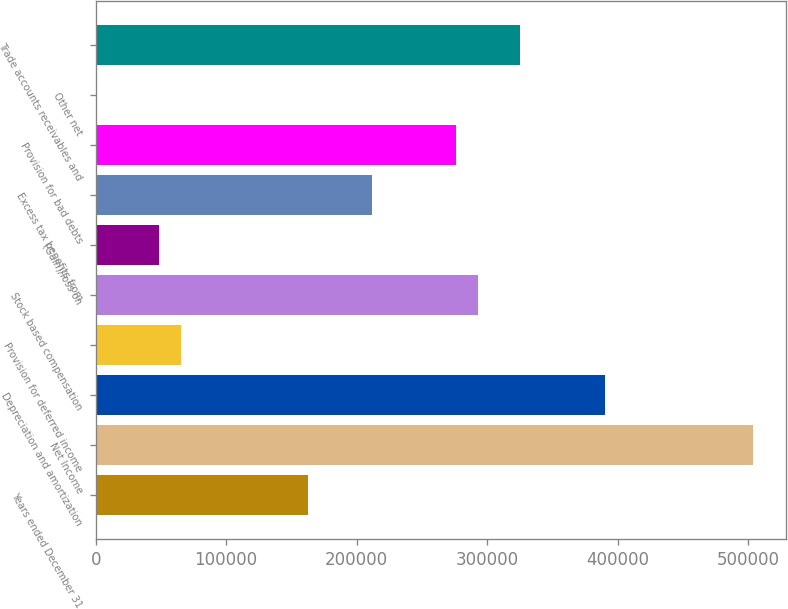<chart> <loc_0><loc_0><loc_500><loc_500><bar_chart><fcel>Years ended December 31<fcel>Net Income<fcel>Depreciation and amortization<fcel>Provision for deferred income<fcel>Stock based compensation<fcel>(Gain)/loss on<fcel>Excess tax benefits from<fcel>Provision for bad debts<fcel>Other net<fcel>Trade accounts receivables and<nl><fcel>162665<fcel>504047<fcel>390253<fcel>65127.2<fcel>292715<fcel>48870.9<fcel>211434<fcel>276459<fcel>102<fcel>325228<nl></chart> 